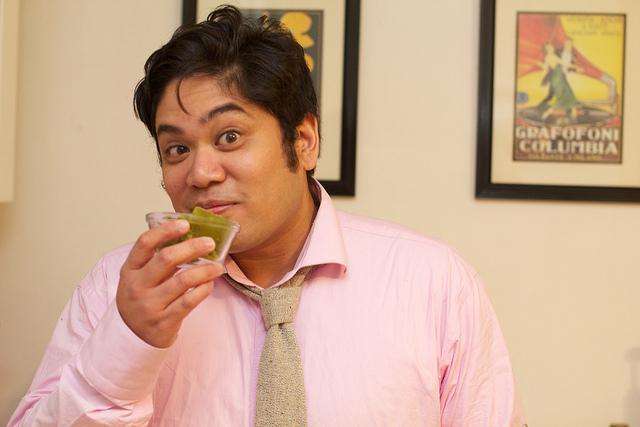How many people are wearing an orange shirt?
Give a very brief answer. 0. 